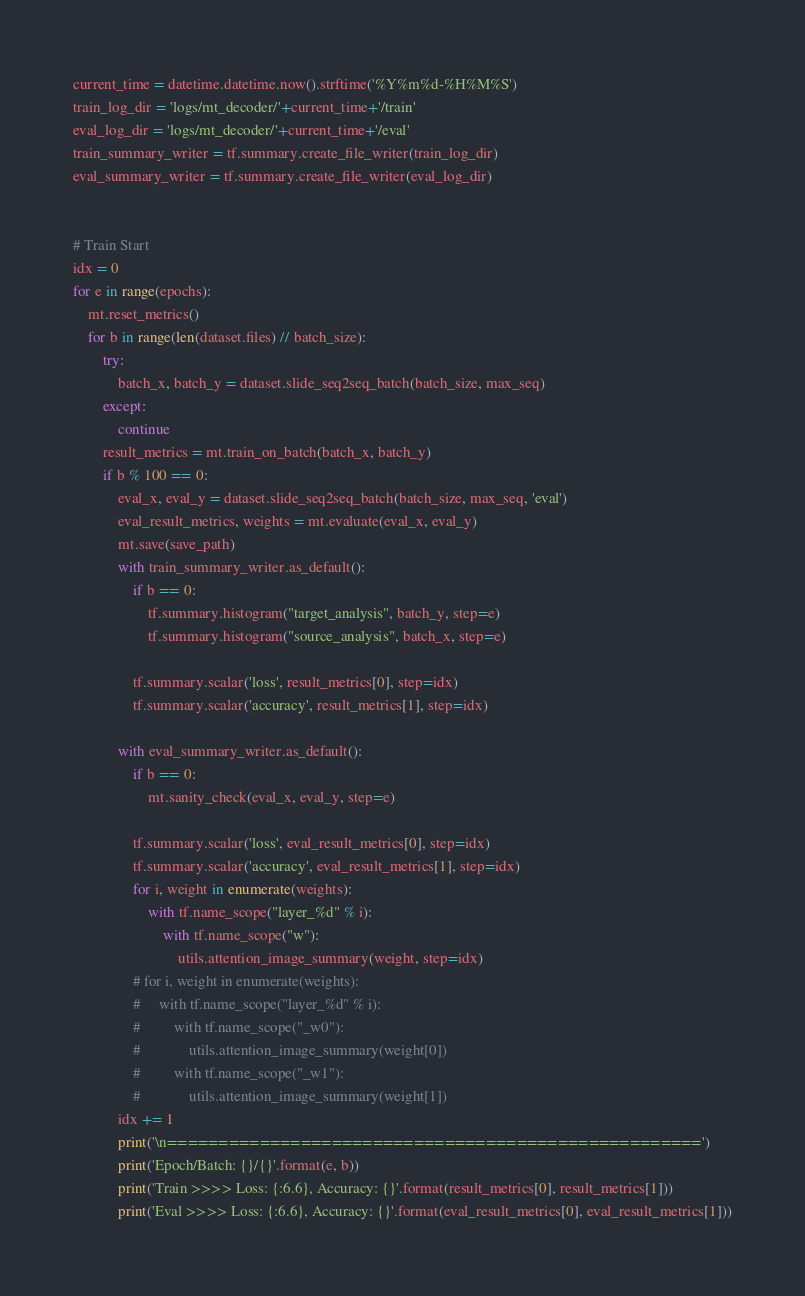Convert code to text. <code><loc_0><loc_0><loc_500><loc_500><_Python_>current_time = datetime.datetime.now().strftime('%Y%m%d-%H%M%S')
train_log_dir = 'logs/mt_decoder/'+current_time+'/train'
eval_log_dir = 'logs/mt_decoder/'+current_time+'/eval'
train_summary_writer = tf.summary.create_file_writer(train_log_dir)
eval_summary_writer = tf.summary.create_file_writer(eval_log_dir)


# Train Start
idx = 0
for e in range(epochs):
    mt.reset_metrics()
    for b in range(len(dataset.files) // batch_size):
        try:
            batch_x, batch_y = dataset.slide_seq2seq_batch(batch_size, max_seq)
        except:
            continue
        result_metrics = mt.train_on_batch(batch_x, batch_y)
        if b % 100 == 0:
            eval_x, eval_y = dataset.slide_seq2seq_batch(batch_size, max_seq, 'eval')
            eval_result_metrics, weights = mt.evaluate(eval_x, eval_y)
            mt.save(save_path)
            with train_summary_writer.as_default():
                if b == 0:
                    tf.summary.histogram("target_analysis", batch_y, step=e)
                    tf.summary.histogram("source_analysis", batch_x, step=e)

                tf.summary.scalar('loss', result_metrics[0], step=idx)
                tf.summary.scalar('accuracy', result_metrics[1], step=idx)

            with eval_summary_writer.as_default():
                if b == 0:
                    mt.sanity_check(eval_x, eval_y, step=e)

                tf.summary.scalar('loss', eval_result_metrics[0], step=idx)
                tf.summary.scalar('accuracy', eval_result_metrics[1], step=idx)
                for i, weight in enumerate(weights):
                    with tf.name_scope("layer_%d" % i):
                        with tf.name_scope("w"):
                            utils.attention_image_summary(weight, step=idx)
                # for i, weight in enumerate(weights):
                #     with tf.name_scope("layer_%d" % i):
                #         with tf.name_scope("_w0"):
                #             utils.attention_image_summary(weight[0])
                #         with tf.name_scope("_w1"):
                #             utils.attention_image_summary(weight[1])
            idx += 1
            print('\n====================================================')
            print('Epoch/Batch: {}/{}'.format(e, b))
            print('Train >>>> Loss: {:6.6}, Accuracy: {}'.format(result_metrics[0], result_metrics[1]))
            print('Eval >>>> Loss: {:6.6}, Accuracy: {}'.format(eval_result_metrics[0], eval_result_metrics[1]))


</code> 